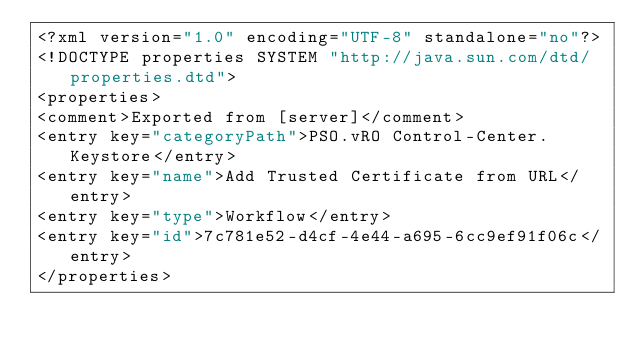<code> <loc_0><loc_0><loc_500><loc_500><_XML_><?xml version="1.0" encoding="UTF-8" standalone="no"?>
<!DOCTYPE properties SYSTEM "http://java.sun.com/dtd/properties.dtd">
<properties>
<comment>Exported from [server]</comment>
<entry key="categoryPath">PSO.vRO Control-Center.Keystore</entry>
<entry key="name">Add Trusted Certificate from URL</entry>
<entry key="type">Workflow</entry>
<entry key="id">7c781e52-d4cf-4e44-a695-6cc9ef91f06c</entry>
</properties>
</code> 